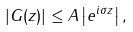<formula> <loc_0><loc_0><loc_500><loc_500>\left | G ( z ) \right | \leq A \left | e ^ { i \sigma z } \right | ,</formula> 